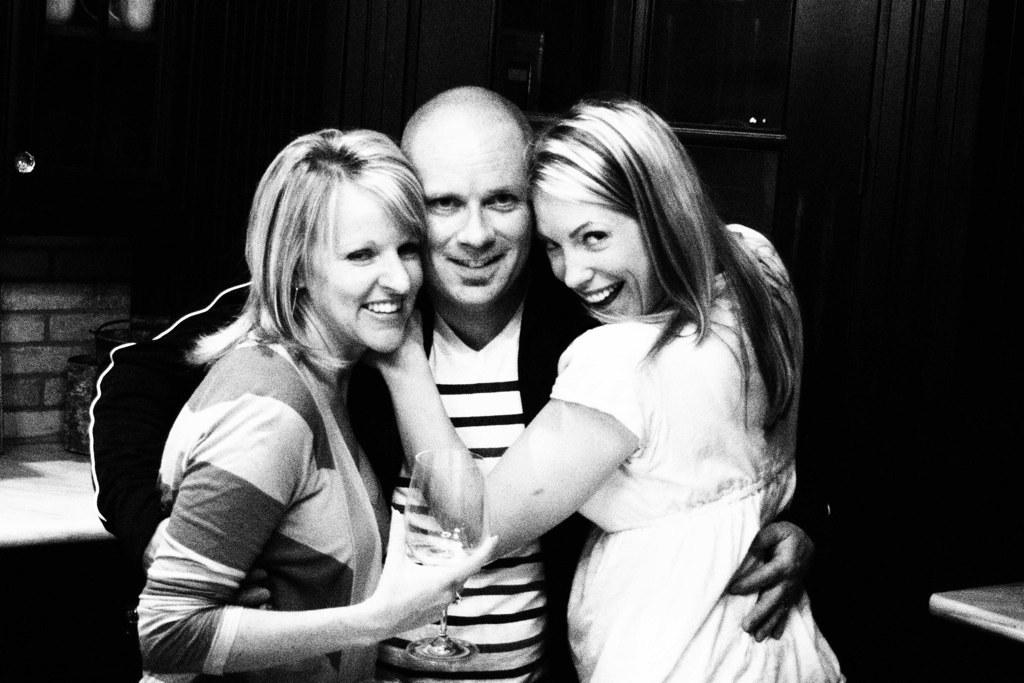Who is the main subject in the middle of the image? There is a man in the middle of the image. Who are the other people in the image? There are two ladies on each side of the man. What is the facial expression of the people in the image? All the people in the image are smiling. What can be seen in the background of the image? There is a building in the background of the image. How would you describe the lighting in the image? The background of the image is dark. What type of card is being used by the man in the image? There is no card present in the image; the man is not using any card. 